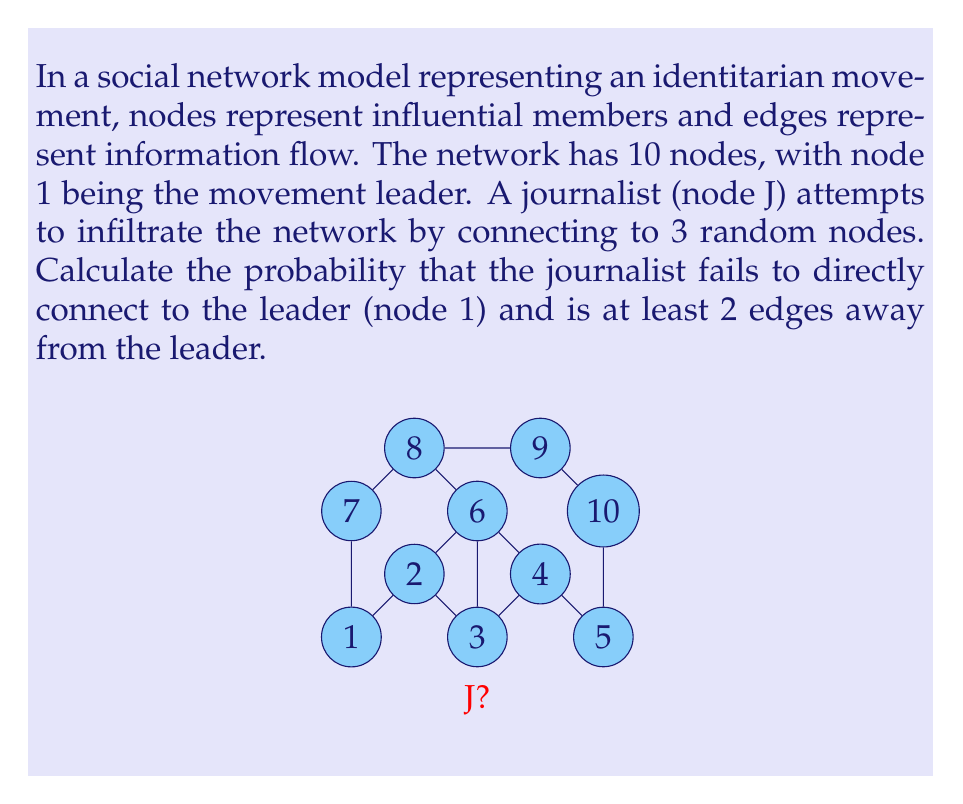Solve this math problem. Let's approach this step-by-step:

1) First, we need to calculate the probability of the journalist not connecting directly to the leader (node 1).
   - The journalist connects to 3 out of 9 possible nodes (excluding themselves).
   - Probability of not connecting to node 1 = $\frac{8}{9} \times \frac{7}{8} \times \frac{6}{7} = \frac{6}{9} = \frac{2}{3}$

2) Now, we need to calculate the probability that the journalist is at least 2 edges away from the leader, given they didn't connect directly.
   - We need to count how many nodes are exactly 1 edge away from the leader.
   - From the diagram, we can see that nodes 2, 7 are directly connected to node 1.
   - Probability of not connecting to these nodes = $\frac{6}{8} \times \frac{5}{7} \times \frac{4}{6} = \frac{20}{56} = \frac{5}{14}$

3) The total probability is the product of these two probabilities:
   $P(\text{not connected to 1 AND at least 2 edges away}) = \frac{2}{3} \times \frac{5}{14} = \frac{10}{42} = \frac{5}{21}$

Therefore, the probability that the journalist fails to directly connect to the leader and is at least 2 edges away is $\frac{5}{21}$.
Answer: $\frac{5}{21}$ 